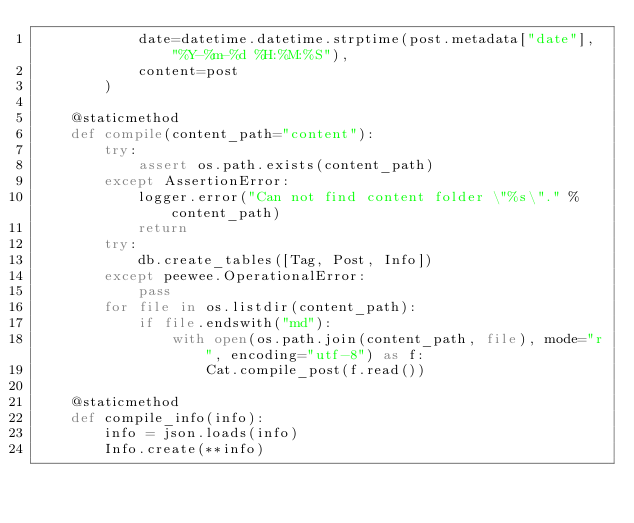Convert code to text. <code><loc_0><loc_0><loc_500><loc_500><_Python_>            date=datetime.datetime.strptime(post.metadata["date"], "%Y-%m-%d %H:%M:%S"),
            content=post
        )

    @staticmethod
    def compile(content_path="content"):
        try:
            assert os.path.exists(content_path)
        except AssertionError:
            logger.error("Can not find content folder \"%s\"." % content_path)
            return
        try:
            db.create_tables([Tag, Post, Info])
        except peewee.OperationalError:
            pass
        for file in os.listdir(content_path):
            if file.endswith("md"):
                with open(os.path.join(content_path, file), mode="r", encoding="utf-8") as f:
                    Cat.compile_post(f.read())

    @staticmethod
    def compile_info(info):
        info = json.loads(info)
        Info.create(**info)
</code> 